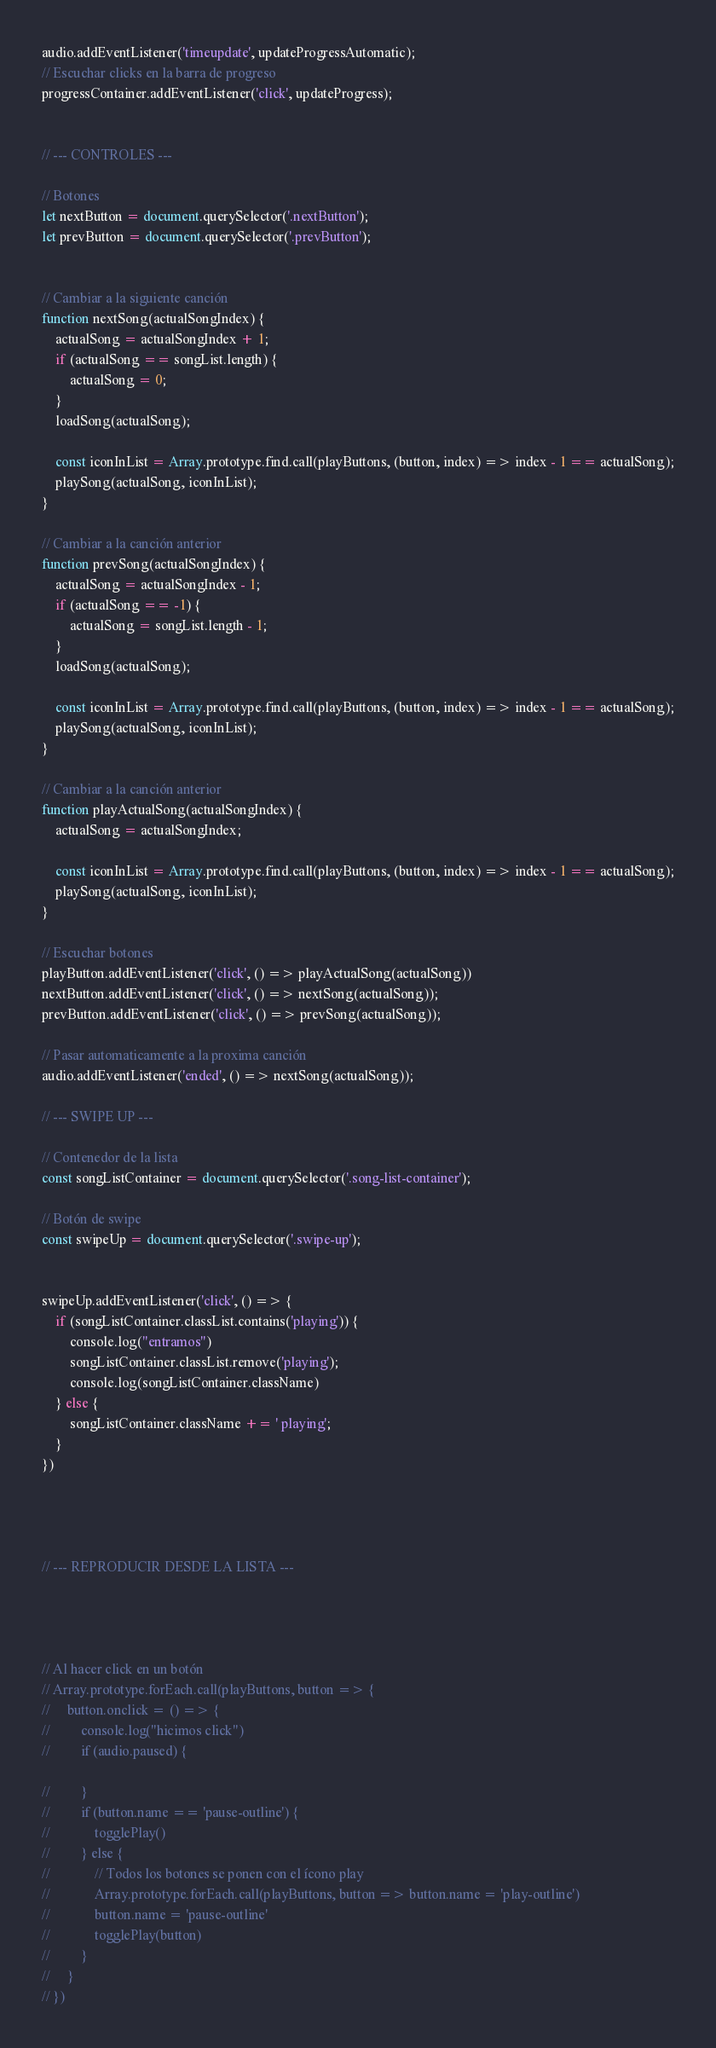Convert code to text. <code><loc_0><loc_0><loc_500><loc_500><_JavaScript_>audio.addEventListener('timeupdate', updateProgressAutomatic);
// Escuchar clicks en la barra de progreso
progressContainer.addEventListener('click', updateProgress);


// --- CONTROLES ---

// Botones
let nextButton = document.querySelector('.nextButton');
let prevButton = document.querySelector('.prevButton');


// Cambiar a la siguiente canción
function nextSong(actualSongIndex) {
    actualSong = actualSongIndex + 1;
    if (actualSong == songList.length) {
        actualSong = 0;
    }
    loadSong(actualSong);

    const iconInList = Array.prototype.find.call(playButtons, (button, index) => index - 1 == actualSong);
    playSong(actualSong, iconInList);
}

// Cambiar a la canción anterior
function prevSong(actualSongIndex) {
    actualSong = actualSongIndex - 1;
    if (actualSong == -1) {
        actualSong = songList.length - 1;
    }
    loadSong(actualSong);

    const iconInList = Array.prototype.find.call(playButtons, (button, index) => index - 1 == actualSong);
    playSong(actualSong, iconInList);
}

// Cambiar a la canción anterior
function playActualSong(actualSongIndex) {
    actualSong = actualSongIndex;

    const iconInList = Array.prototype.find.call(playButtons, (button, index) => index - 1 == actualSong);
    playSong(actualSong, iconInList);
}

// Escuchar botones
playButton.addEventListener('click', () => playActualSong(actualSong))
nextButton.addEventListener('click', () => nextSong(actualSong));
prevButton.addEventListener('click', () => prevSong(actualSong));

// Pasar automaticamente a la proxima canción
audio.addEventListener('ended', () => nextSong(actualSong));

// --- SWIPE UP ---

// Contenedor de la lista
const songListContainer = document.querySelector('.song-list-container');

// Botón de swipe
const swipeUp = document.querySelector('.swipe-up');
    

swipeUp.addEventListener('click', () => {
    if (songListContainer.classList.contains('playing')) {
        console.log("entramos")
        songListContainer.classList.remove('playing');
        console.log(songListContainer.className)
    } else {
        songListContainer.className += ' playing';
    }
})




// --- REPRODUCIR DESDE LA LISTA ---




// Al hacer click en un botón
// Array.prototype.forEach.call(playButtons, button => {
//     button.onclick = () => {
//         console.log("hicimos click")
//         if (audio.paused) {

//         }
//         if (button.name == 'pause-outline') {
//             togglePlay()
//         } else {
//             // Todos los botones se ponen con el ícono play
//             Array.prototype.forEach.call(playButtons, button => button.name = 'play-outline')
//             button.name = 'pause-outline'
//             togglePlay(button)
//         }
//     }
// })</code> 